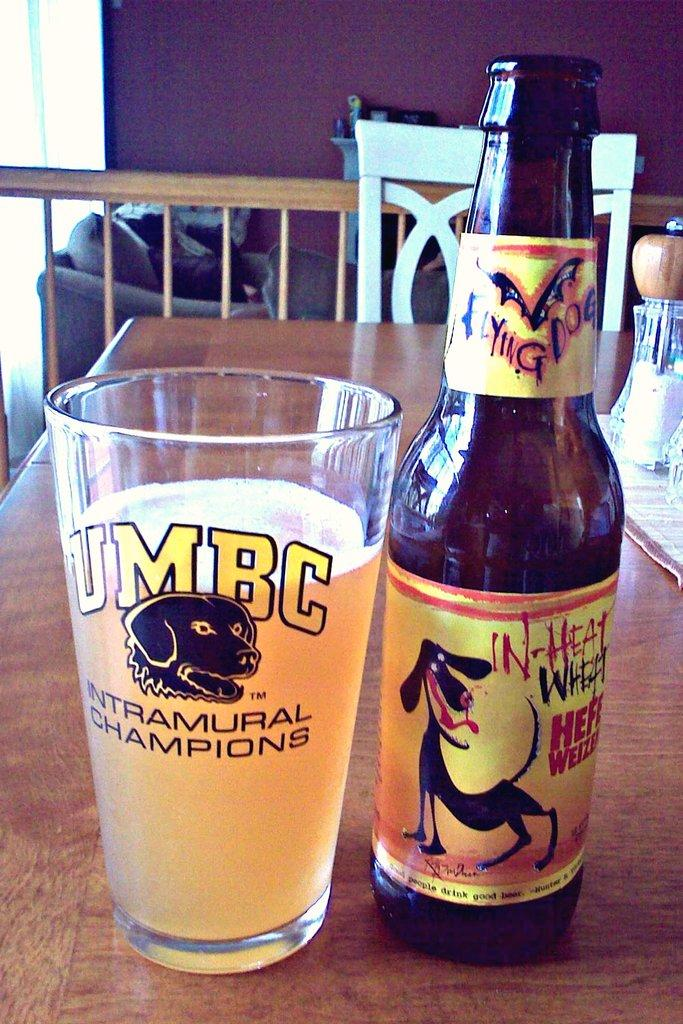Provide a one-sentence caption for the provided image. a UMBC glass that has a dog on it. 